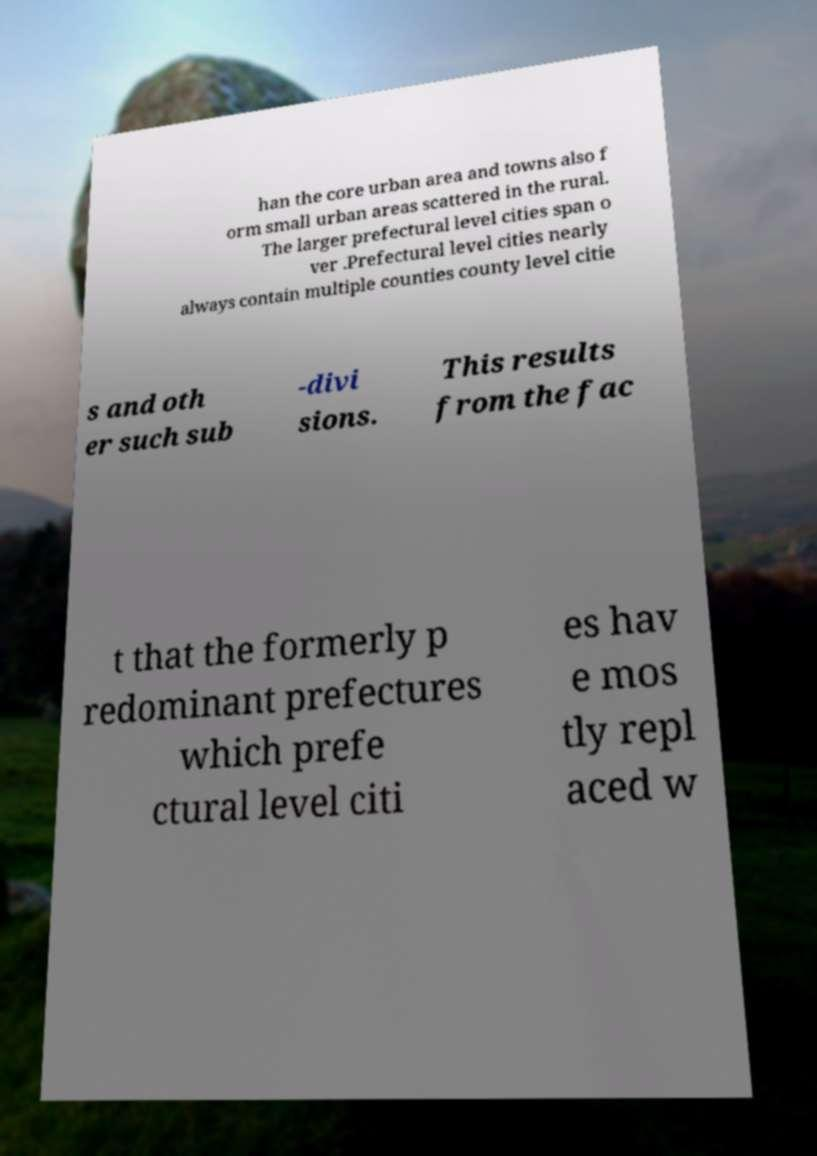There's text embedded in this image that I need extracted. Can you transcribe it verbatim? han the core urban area and towns also f orm small urban areas scattered in the rural. The larger prefectural level cities span o ver .Prefectural level cities nearly always contain multiple counties county level citie s and oth er such sub -divi sions. This results from the fac t that the formerly p redominant prefectures which prefe ctural level citi es hav e mos tly repl aced w 